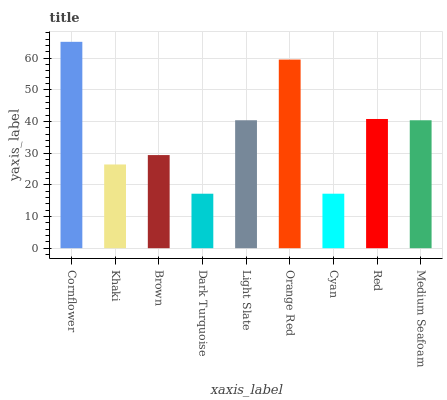Is Dark Turquoise the minimum?
Answer yes or no. Yes. Is Cornflower the maximum?
Answer yes or no. Yes. Is Khaki the minimum?
Answer yes or no. No. Is Khaki the maximum?
Answer yes or no. No. Is Cornflower greater than Khaki?
Answer yes or no. Yes. Is Khaki less than Cornflower?
Answer yes or no. Yes. Is Khaki greater than Cornflower?
Answer yes or no. No. Is Cornflower less than Khaki?
Answer yes or no. No. Is Medium Seafoam the high median?
Answer yes or no. Yes. Is Medium Seafoam the low median?
Answer yes or no. Yes. Is Light Slate the high median?
Answer yes or no. No. Is Light Slate the low median?
Answer yes or no. No. 